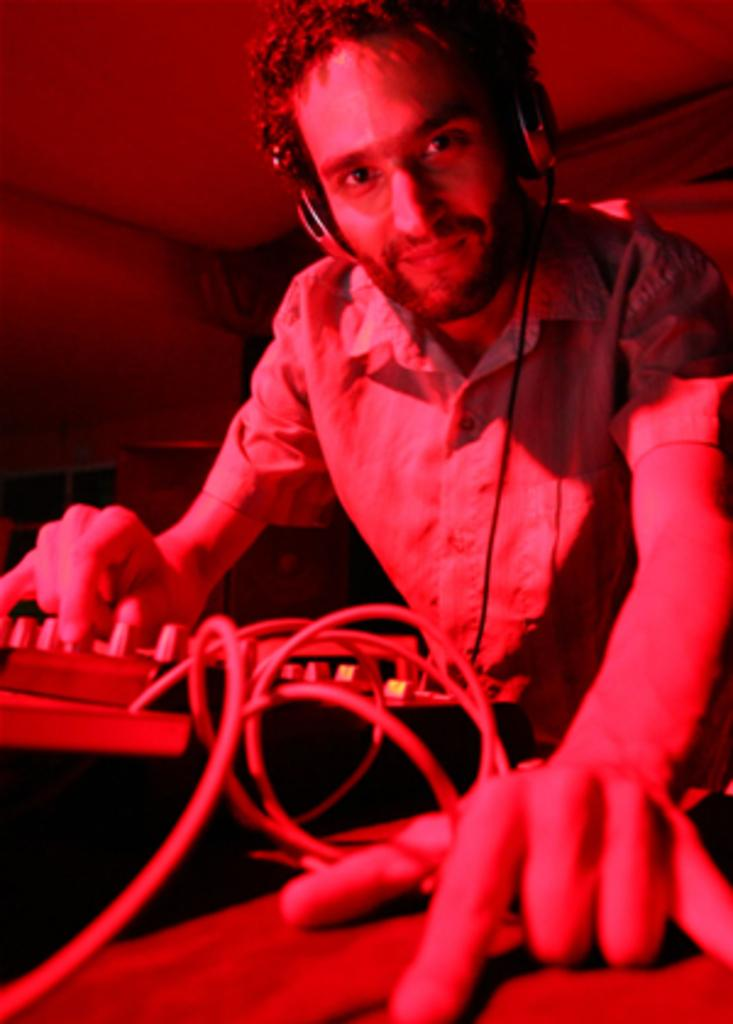What is the person in the image doing? The person is operating an electronic instrument. What is the person wearing that might be related to their activity? The person is wearing headphones. What can be seen behind the person in the image? There are objects behind the person. What type of background is visible in the image? There is a wall visible in the image. What type of grass is growing on the wall in the image? There is no grass visible in the image, only a wall. 